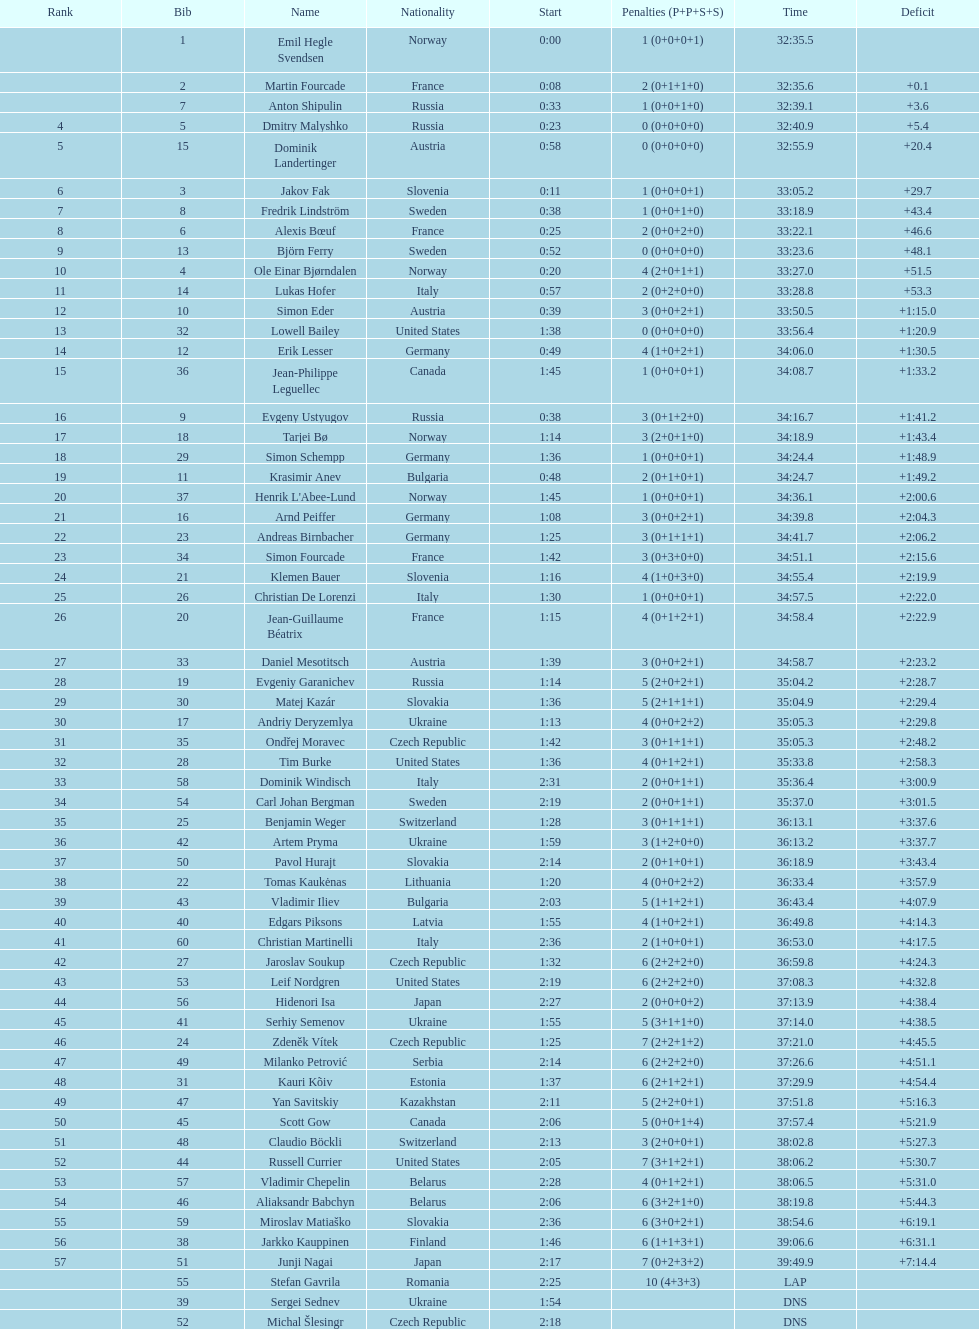What were the total number of "ties" (people who finished with the exact same time?) 2. 